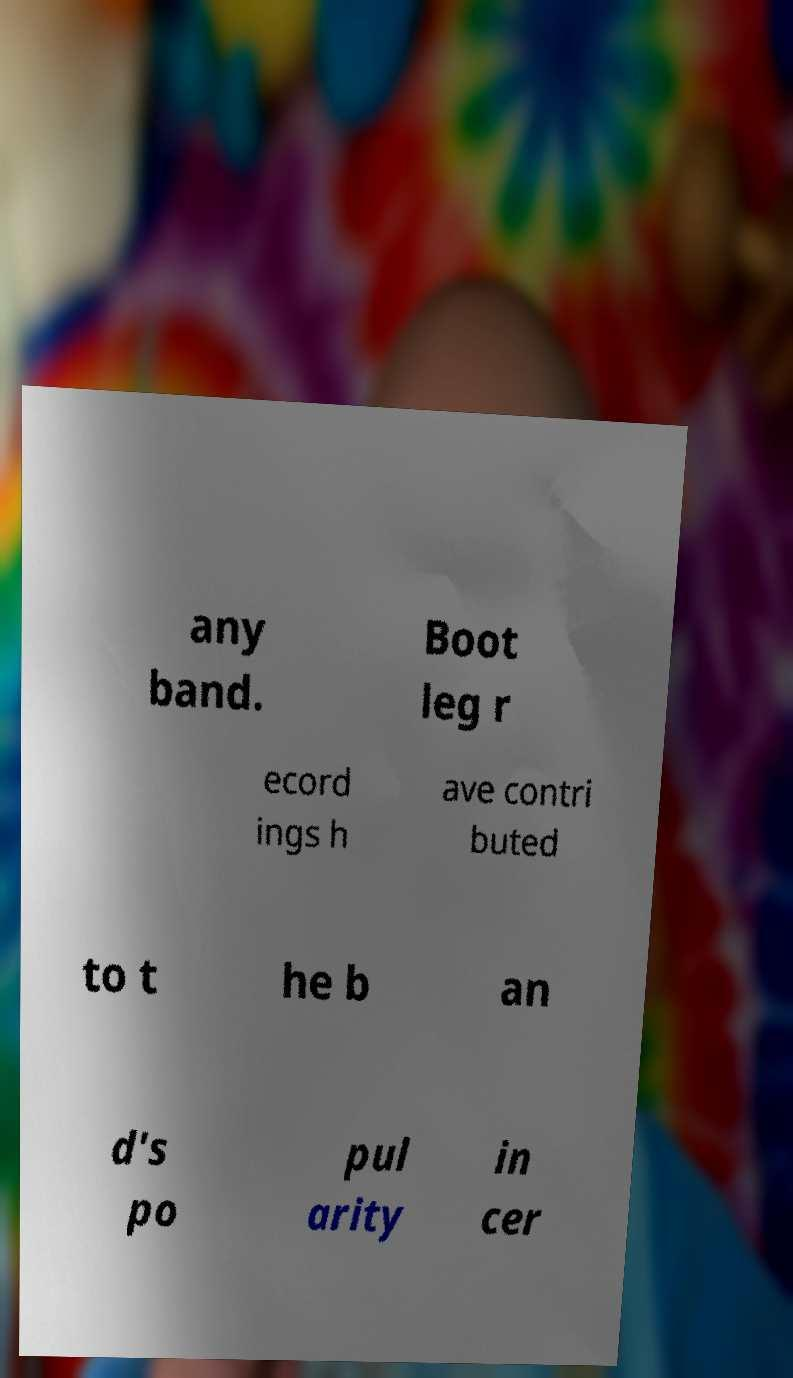Could you assist in decoding the text presented in this image and type it out clearly? any band. Boot leg r ecord ings h ave contri buted to t he b an d's po pul arity in cer 